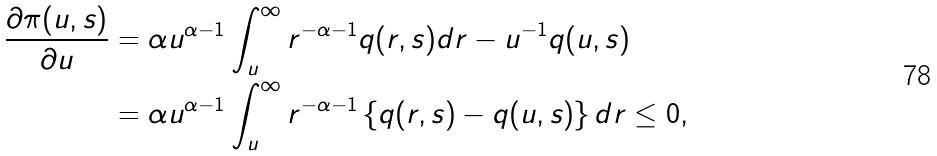<formula> <loc_0><loc_0><loc_500><loc_500>\frac { \partial \pi ( u , s ) } { \partial u } & = \alpha u ^ { \alpha - 1 } \int _ { u } ^ { \infty } r ^ { - \alpha - 1 } q ( r , s ) d r - u ^ { - 1 } q ( u , s ) \\ & = \alpha u ^ { \alpha - 1 } \int _ { u } ^ { \infty } r ^ { - \alpha - 1 } \left \{ q ( r , s ) - q ( u , s ) \right \} d r \leq 0 ,</formula> 